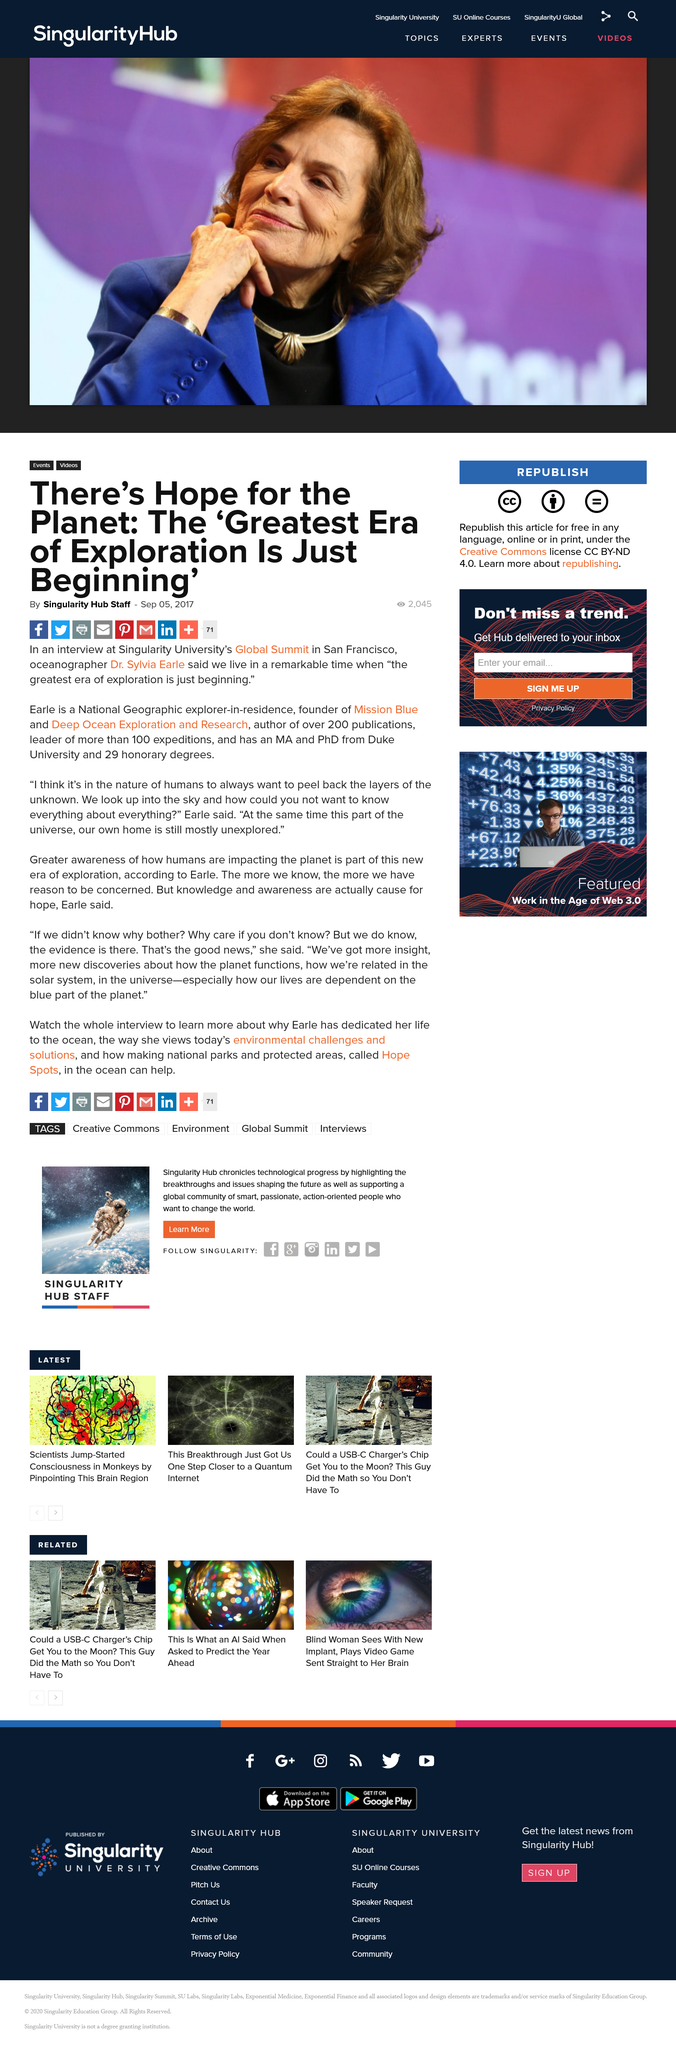Draw attention to some important aspects in this diagram. Dr. Sylvia Earle has 29 honorary degrees. The interview took place at Singularity University's Global Summit, which was held in San Francisco. Dr. Sylvia Earle has released over 200 publications during her career. 